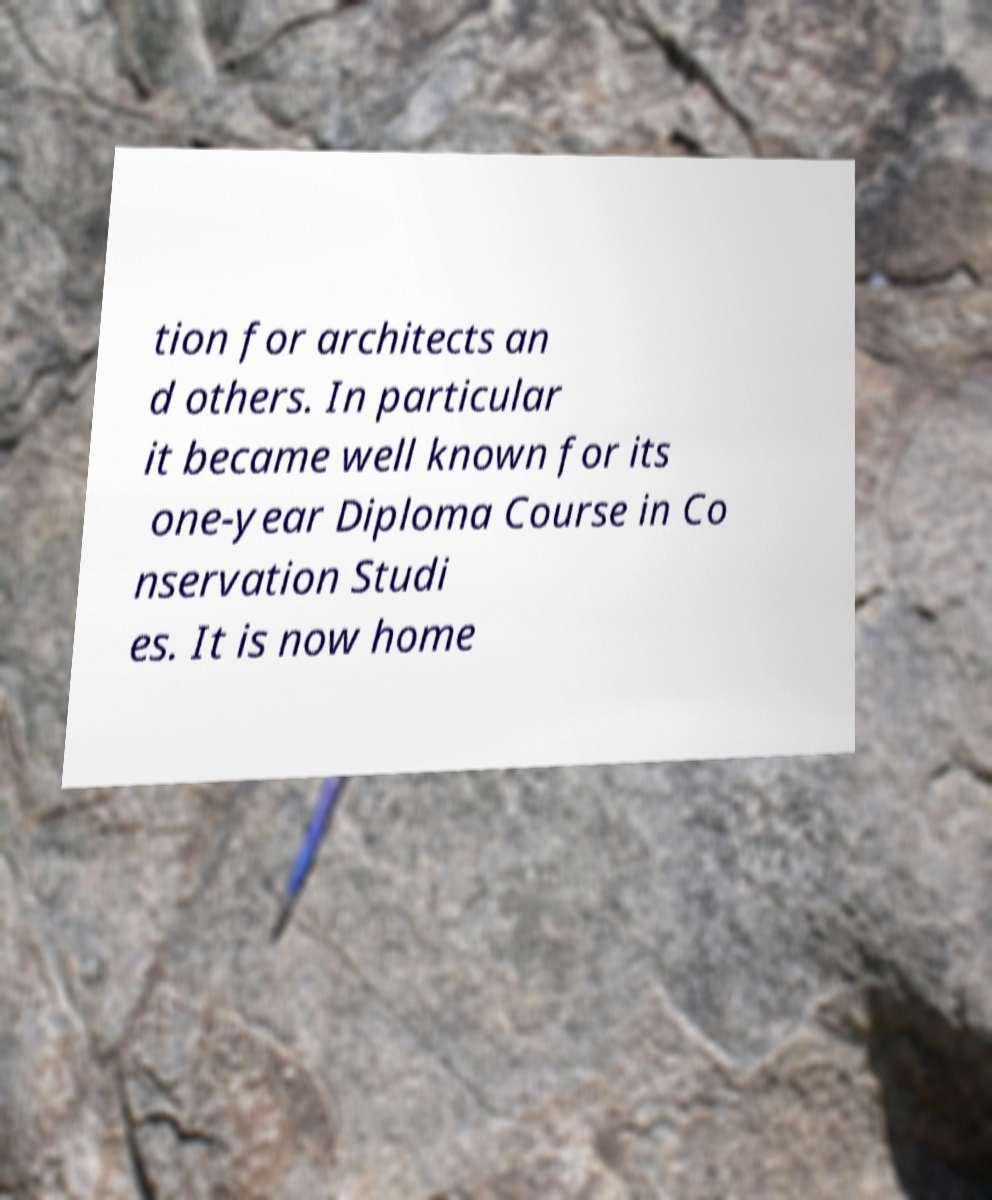Can you read and provide the text displayed in the image?This photo seems to have some interesting text. Can you extract and type it out for me? tion for architects an d others. In particular it became well known for its one-year Diploma Course in Co nservation Studi es. It is now home 